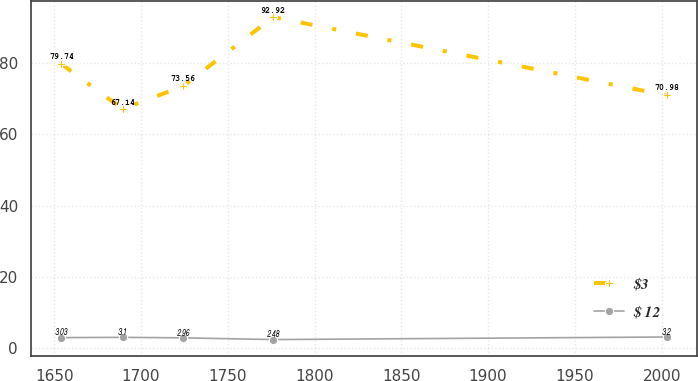Convert chart. <chart><loc_0><loc_0><loc_500><loc_500><line_chart><ecel><fcel>$3<fcel>$ 12<nl><fcel>1654.22<fcel>79.74<fcel>3.03<nl><fcel>1689.45<fcel>67.14<fcel>3.1<nl><fcel>1724.31<fcel>73.56<fcel>2.96<nl><fcel>1776.22<fcel>92.92<fcel>2.48<nl><fcel>2002.8<fcel>70.98<fcel>3.2<nl></chart> 